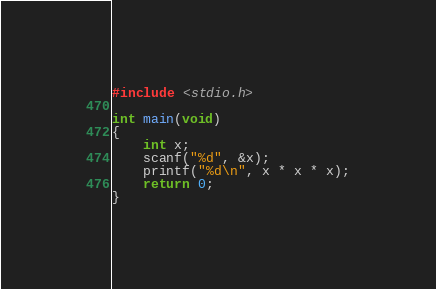Convert code to text. <code><loc_0><loc_0><loc_500><loc_500><_C_>#include <stdio.h>

int main(void)
{
    int x;
    scanf("%d", &x);
    printf("%d\n", x * x * x);
    return 0;
}</code> 